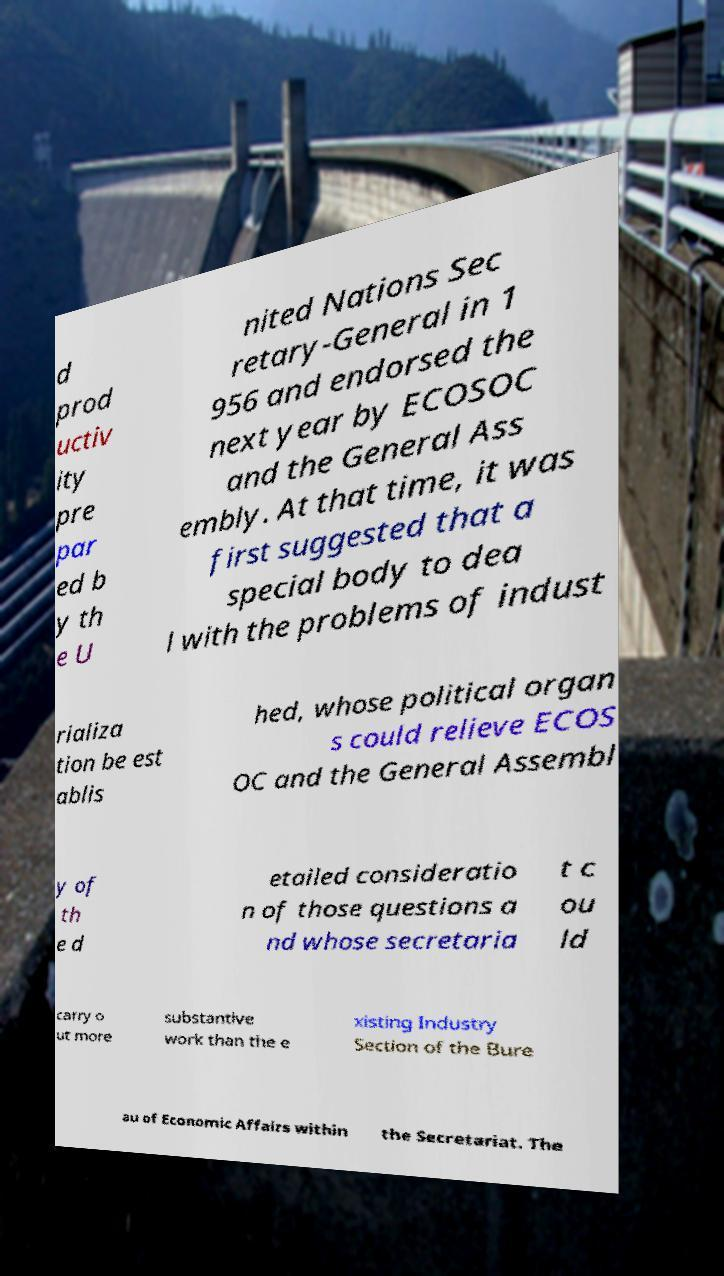Could you extract and type out the text from this image? d prod uctiv ity pre par ed b y th e U nited Nations Sec retary-General in 1 956 and endorsed the next year by ECOSOC and the General Ass embly. At that time, it was first suggested that a special body to dea l with the problems of indust rializa tion be est ablis hed, whose political organ s could relieve ECOS OC and the General Assembl y of th e d etailed consideratio n of those questions a nd whose secretaria t c ou ld carry o ut more substantive work than the e xisting Industry Section of the Bure au of Economic Affairs within the Secretariat. The 